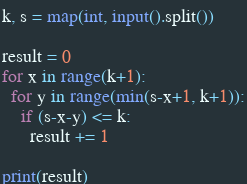Convert code to text. <code><loc_0><loc_0><loc_500><loc_500><_Python_>k, s = map(int, input().split())

result = 0
for x in range(k+1):
  for y in range(min(s-x+1, k+1)):
    if (s-x-y) <= k:
      result += 1

print(result)</code> 